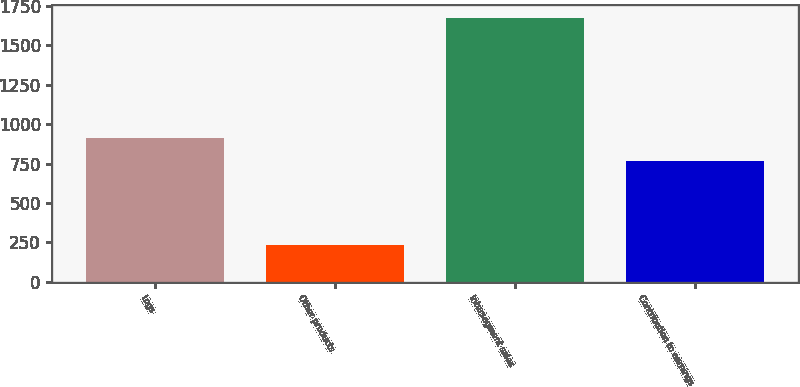Convert chart to OTSL. <chart><loc_0><loc_0><loc_500><loc_500><bar_chart><fcel>Logs<fcel>Other products<fcel>Intersegment sales<fcel>Contribution to earnings<nl><fcel>911<fcel>235<fcel>1675<fcel>767<nl></chart> 